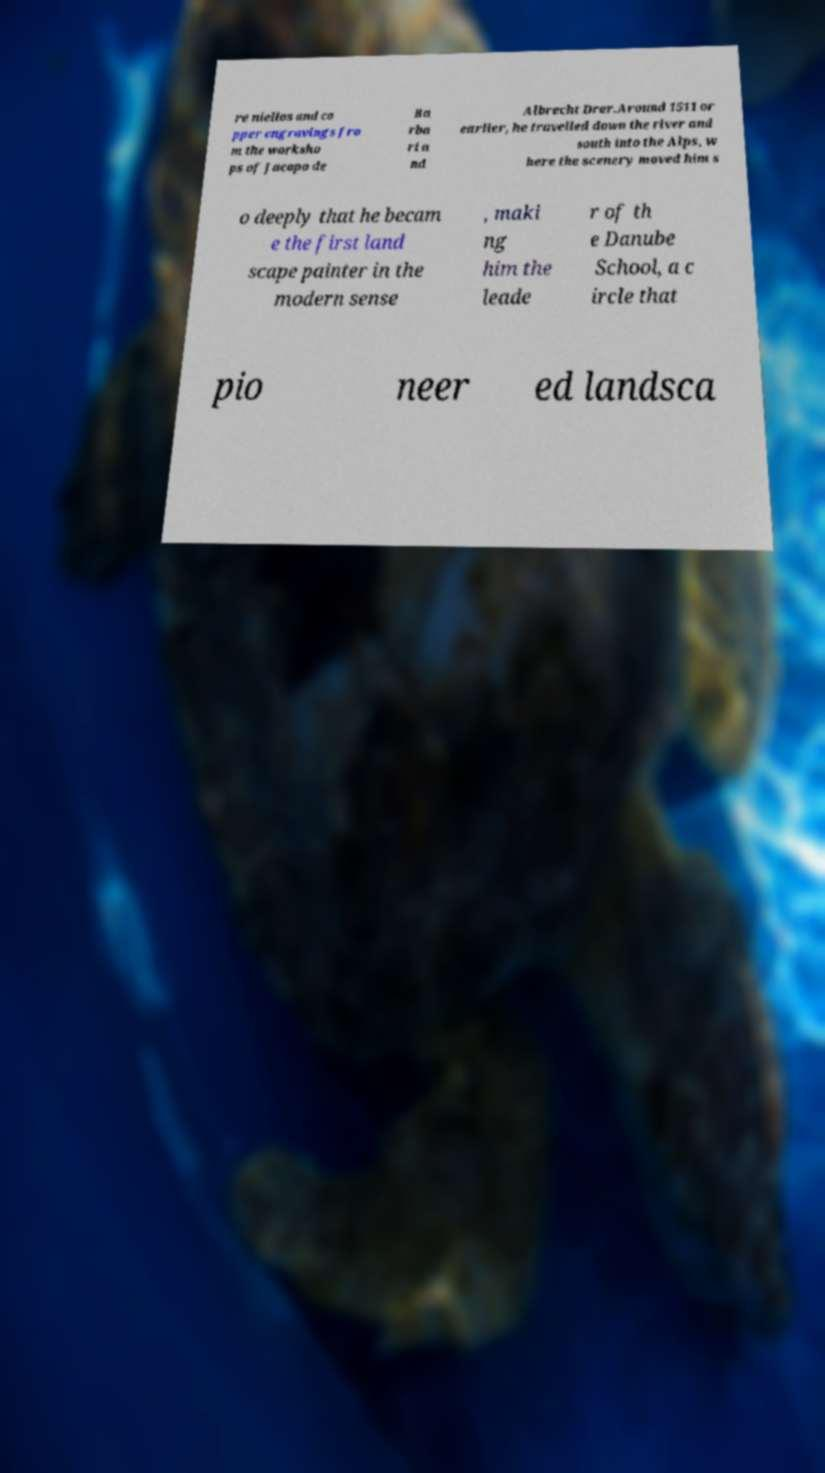What messages or text are displayed in this image? I need them in a readable, typed format. re niellos and co pper engravings fro m the worksho ps of Jacopo de Ba rba ri a nd Albrecht Drer.Around 1511 or earlier, he travelled down the river and south into the Alps, w here the scenery moved him s o deeply that he becam e the first land scape painter in the modern sense , maki ng him the leade r of th e Danube School, a c ircle that pio neer ed landsca 